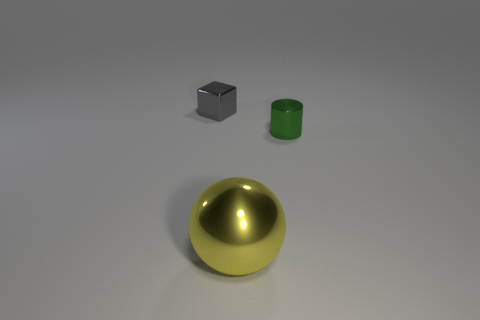Add 2 tiny red balls. How many objects exist? 5 Subtract all spheres. How many objects are left? 2 Add 3 small gray metal blocks. How many small gray metal blocks exist? 4 Subtract 0 blue cubes. How many objects are left? 3 Subtract all big cyan matte objects. Subtract all large yellow balls. How many objects are left? 2 Add 1 small green cylinders. How many small green cylinders are left? 2 